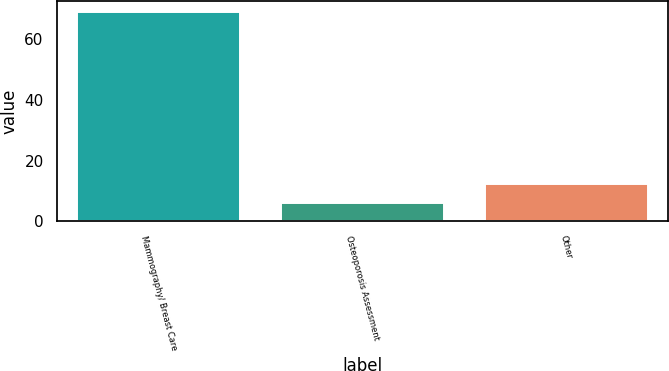<chart> <loc_0><loc_0><loc_500><loc_500><bar_chart><fcel>Mammography/ Breast Care<fcel>Osteoporosis Assessment<fcel>Other<nl><fcel>69<fcel>6<fcel>12.3<nl></chart> 